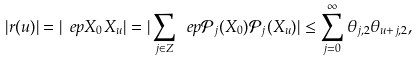Convert formula to latex. <formula><loc_0><loc_0><loc_500><loc_500>| r ( u ) | = | \ e p X _ { 0 } X _ { u } | = | \sum _ { j \in Z } \ e p \mathcal { P } _ { j } ( X _ { 0 } ) \mathcal { P } _ { j } ( X _ { u } ) | \leq \sum _ { j = 0 } ^ { \infty } \theta _ { j , 2 } \theta _ { u + j , 2 } ,</formula> 